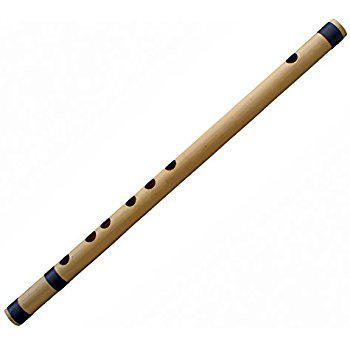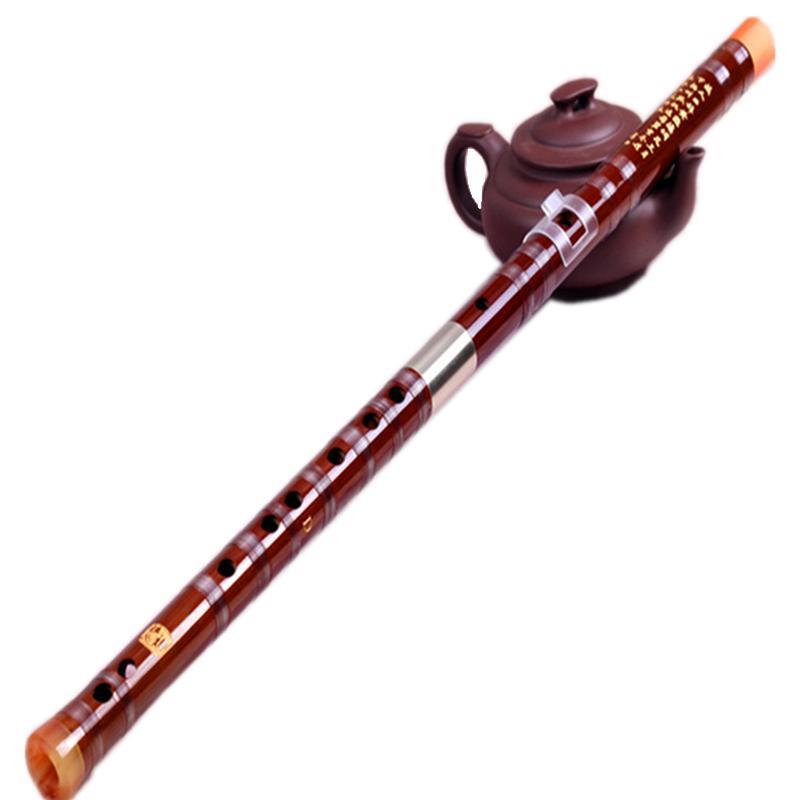The first image is the image on the left, the second image is the image on the right. For the images shown, is this caption "The left image contains twice as many flutes as the right image." true? Answer yes or no. No. The first image is the image on the left, the second image is the image on the right. Examine the images to the left and right. Is the description "There are exactly two instruments in total." accurate? Answer yes or no. Yes. 